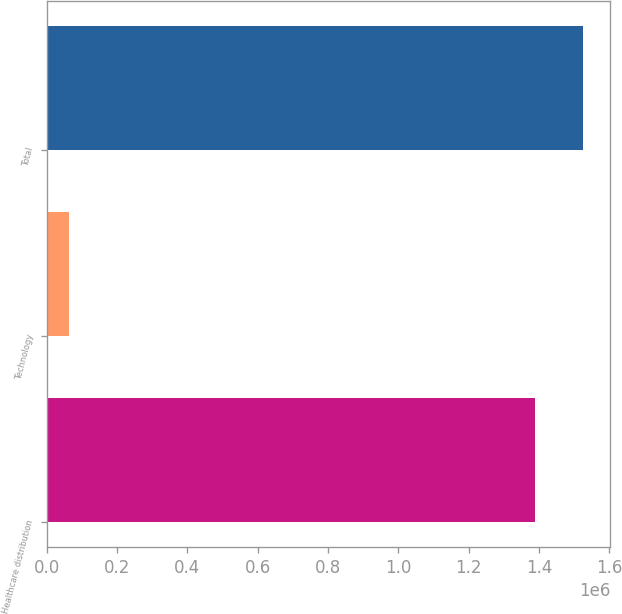Convert chart to OTSL. <chart><loc_0><loc_0><loc_500><loc_500><bar_chart><fcel>Healthcare distribution<fcel>Technology<fcel>Total<nl><fcel>1.38758e+06<fcel>62134<fcel>1.52634e+06<nl></chart> 